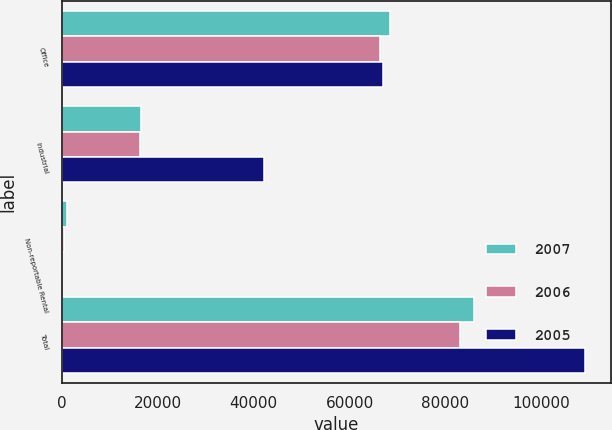Convert chart to OTSL. <chart><loc_0><loc_0><loc_500><loc_500><stacked_bar_chart><ecel><fcel>Office<fcel>Industrial<fcel>Non-reportable Rental<fcel>Total<nl><fcel>2007<fcel>68427<fcel>16454<fcel>1055<fcel>85936<nl><fcel>2006<fcel>66449<fcel>16210<fcel>341<fcel>83000<nl><fcel>2005<fcel>66890<fcel>42083<fcel>67<fcel>109040<nl></chart> 